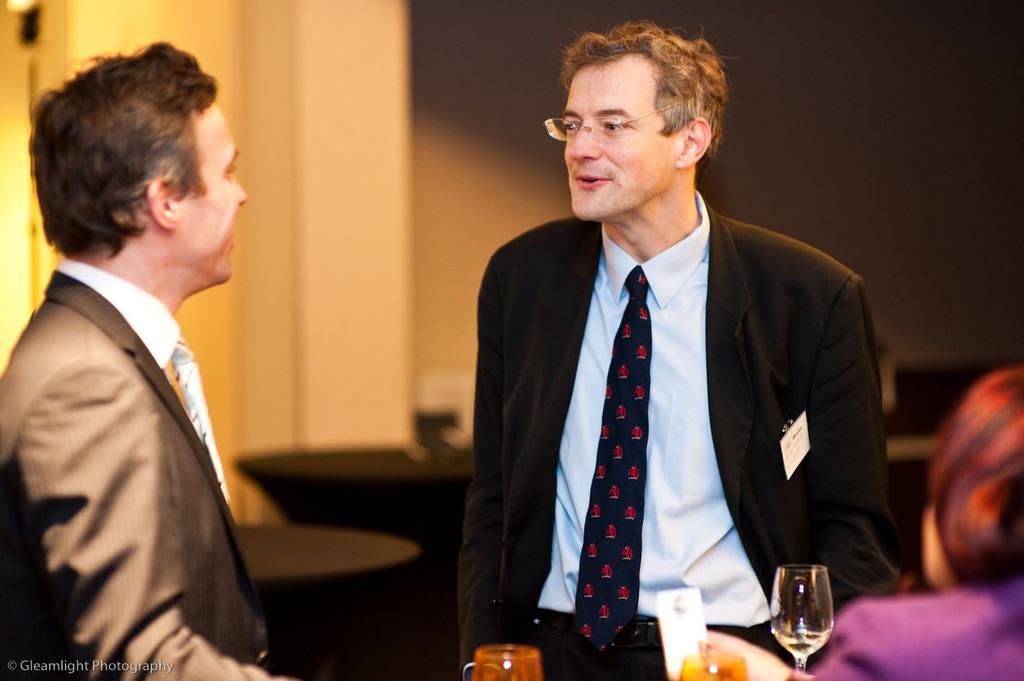Please provide a concise description of this image. This picture is clicked inside the room. On the right bottom of the picture, we see woman in purple blazer is sitting on chair and in front of her, we see a man in blue shirt and black blazer is standing and talking to the man on the opposite side, who is wearing brown blazer and white shirt. Beside them, we see black tables and beside these tables, we see pillar and a wall. 